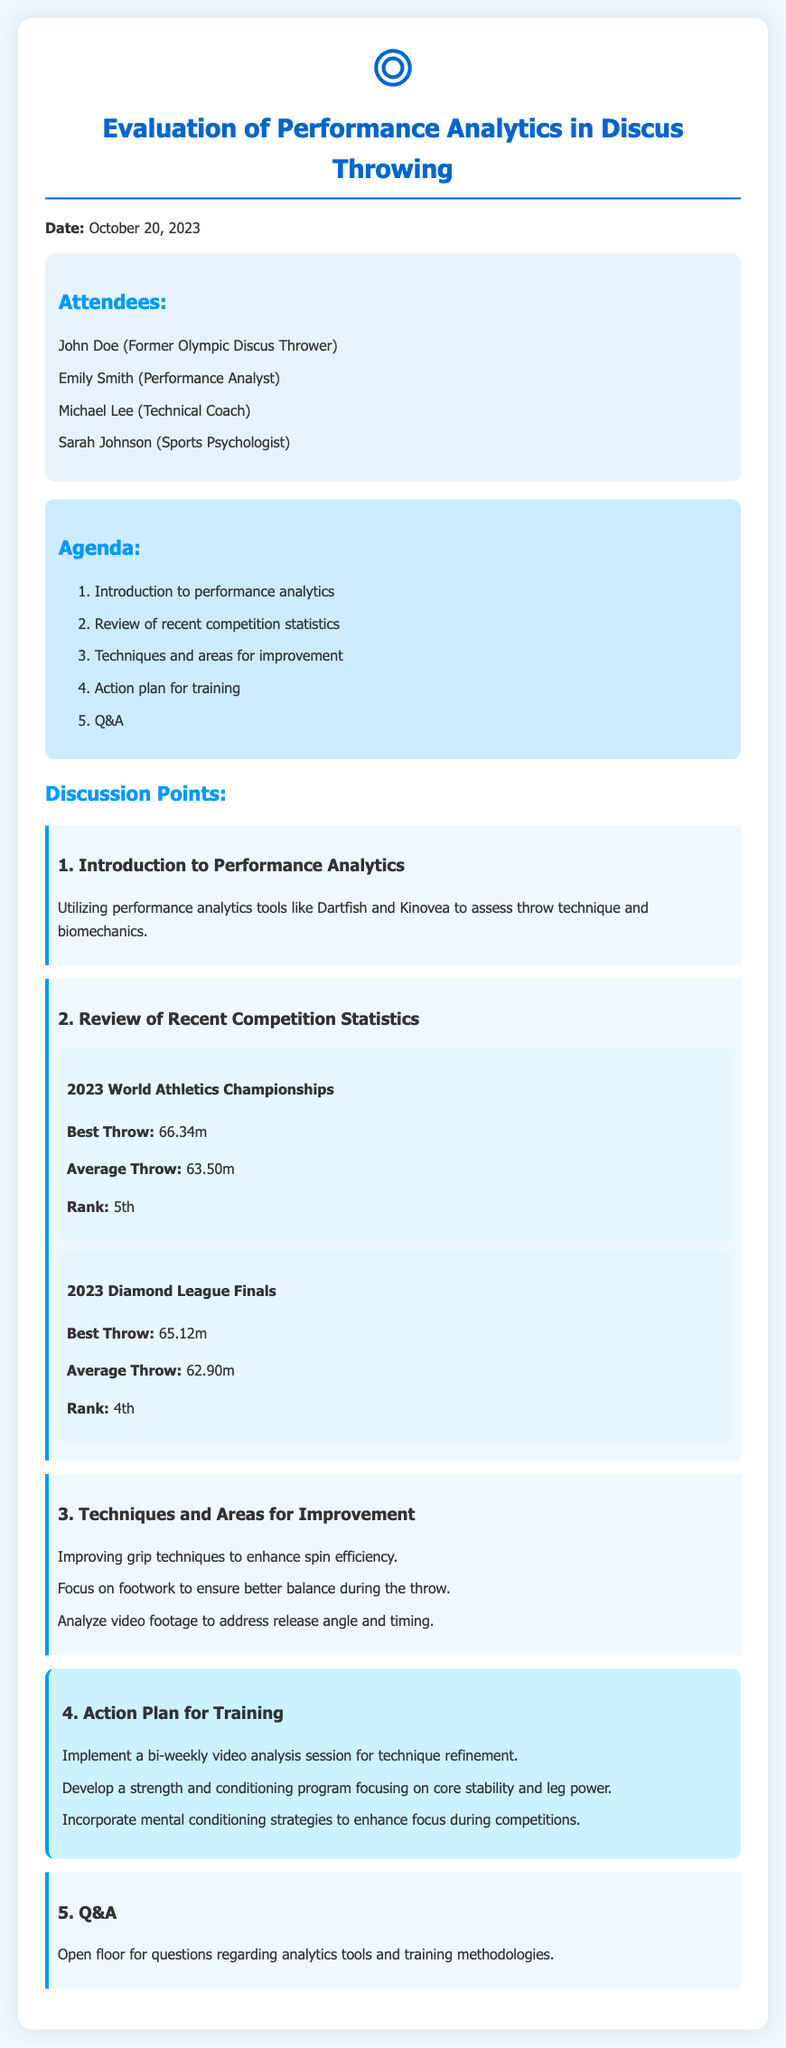What date was the meeting held? The document states that the meeting took place on October 20, 2023.
Answer: October 20, 2023 Who were the attendees of the meeting? The attendees section lists four individuals who participated in the meeting.
Answer: John Doe, Emily Smith, Michael Lee, Sarah Johnson What was the best throw at the 2023 World Athletics Championships? The best throw statistic is specified for the 2023 World Athletics Championships in the document.
Answer: 66.34m What is one technique that is suggested for improvement? The document lists several areas for improvement regarding discus throwing technique.
Answer: Improving grip techniques How often will video analysis sessions be held? The action plan mentions the frequency of video analysis sessions intended for technique refinement.
Answer: Bi-weekly What was the average throw in the 2023 Diamond League Finals? The average throw statistic is specified for the 2023 Diamond League Finals in the document.
Answer: 62.90m How many discussion points were listed in the minutes? The document outlines the main areas of discussion during the meeting.
Answer: Five What is the rank achieved at the 2023 Diamond League Finals? The rank obtained during the 2023 Diamond League Finals is mentioned in the statistics.
Answer: 4th 